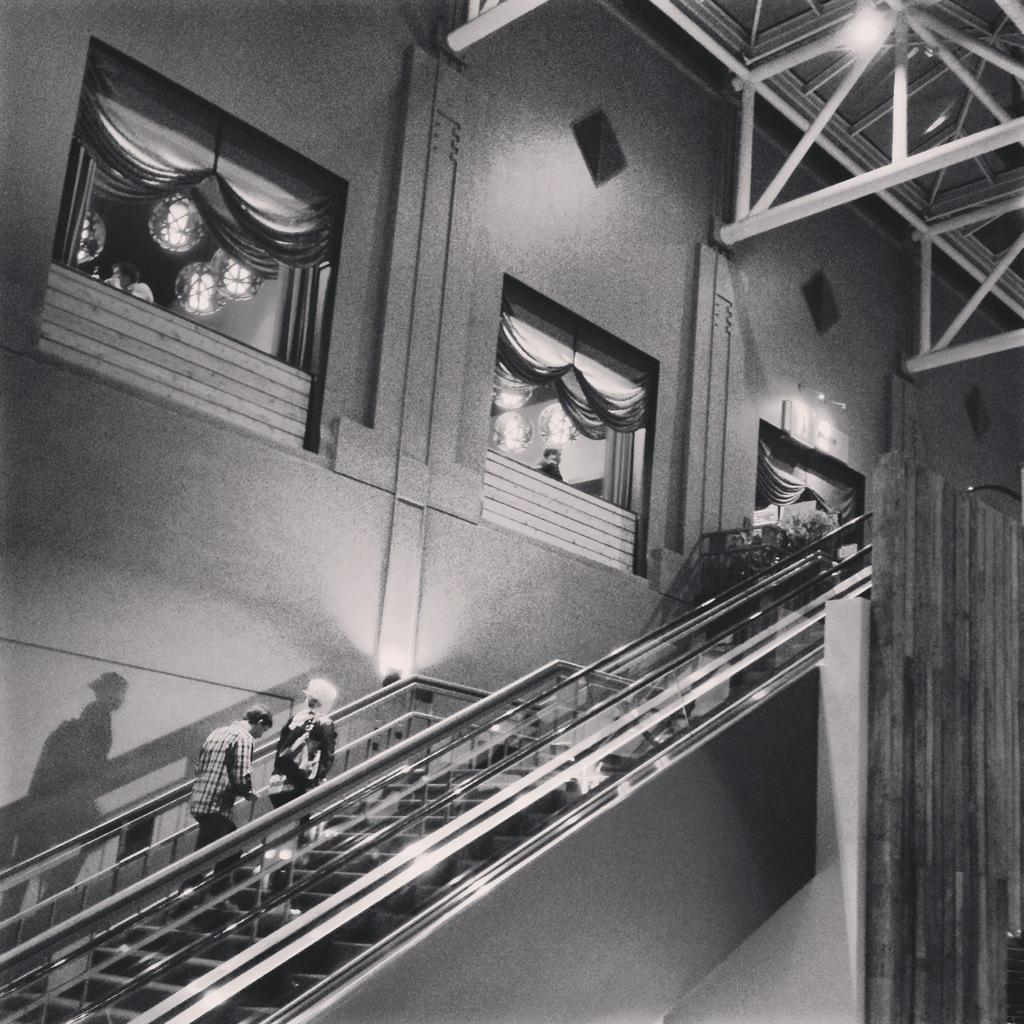What structure is present in the image that people are using? There is a staircase in the image, and people are standing on it. What else can be seen in the image besides the staircase? There is a wall in the image. Is there any source of light visible in the image? Yes, there is a light visible in the image. What is the color scheme of the image? The image is in black and white. What type of ring is being worn by the person standing on the staircase? There is no ring visible on any person in the image. What angle is the staircase positioned at in the image? The angle of the staircase cannot be determined from the image, as it is a two-dimensional representation. 